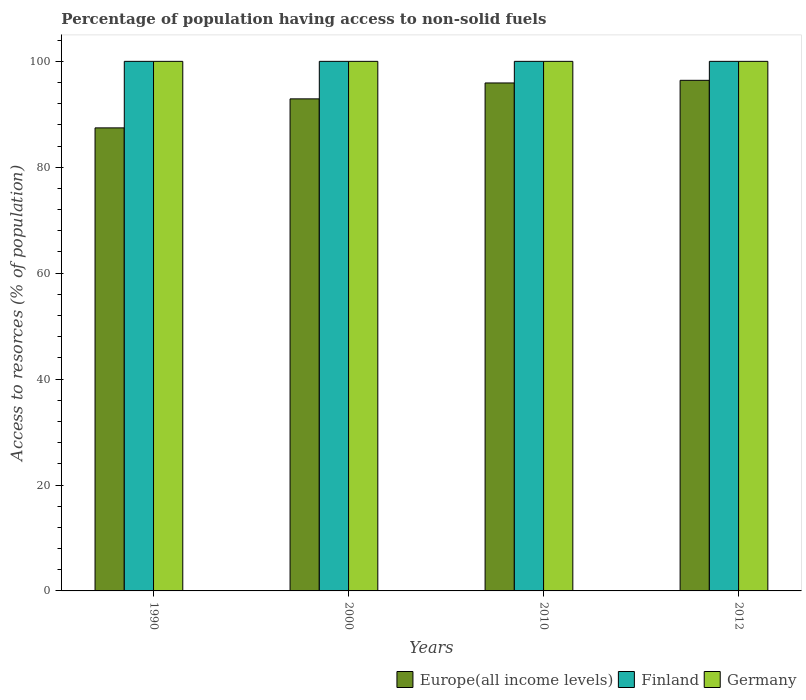How many groups of bars are there?
Provide a succinct answer. 4. Are the number of bars on each tick of the X-axis equal?
Offer a very short reply. Yes. How many bars are there on the 1st tick from the left?
Give a very brief answer. 3. How many bars are there on the 1st tick from the right?
Your answer should be very brief. 3. What is the label of the 1st group of bars from the left?
Ensure brevity in your answer.  1990. In how many cases, is the number of bars for a given year not equal to the number of legend labels?
Provide a short and direct response. 0. What is the percentage of population having access to non-solid fuels in Germany in 2012?
Give a very brief answer. 100. Across all years, what is the maximum percentage of population having access to non-solid fuels in Germany?
Provide a succinct answer. 100. Across all years, what is the minimum percentage of population having access to non-solid fuels in Europe(all income levels)?
Provide a succinct answer. 87.44. What is the total percentage of population having access to non-solid fuels in Finland in the graph?
Your response must be concise. 400. What is the difference between the percentage of population having access to non-solid fuels in Europe(all income levels) in 1990 and that in 2010?
Provide a short and direct response. -8.49. What is the difference between the percentage of population having access to non-solid fuels in Finland in 2012 and the percentage of population having access to non-solid fuels in Germany in 1990?
Give a very brief answer. 0. What is the average percentage of population having access to non-solid fuels in Germany per year?
Your response must be concise. 100. In the year 2010, what is the difference between the percentage of population having access to non-solid fuels in Europe(all income levels) and percentage of population having access to non-solid fuels in Germany?
Your answer should be very brief. -4.08. What is the ratio of the percentage of population having access to non-solid fuels in Germany in 2010 to that in 2012?
Ensure brevity in your answer.  1. Is the difference between the percentage of population having access to non-solid fuels in Europe(all income levels) in 1990 and 2010 greater than the difference between the percentage of population having access to non-solid fuels in Germany in 1990 and 2010?
Offer a terse response. No. What is the difference between the highest and the second highest percentage of population having access to non-solid fuels in Finland?
Provide a succinct answer. 0. Is the sum of the percentage of population having access to non-solid fuels in Germany in 2000 and 2010 greater than the maximum percentage of population having access to non-solid fuels in Finland across all years?
Your response must be concise. Yes. What does the 1st bar from the left in 2012 represents?
Ensure brevity in your answer.  Europe(all income levels). Are all the bars in the graph horizontal?
Give a very brief answer. No. Does the graph contain any zero values?
Make the answer very short. No. How many legend labels are there?
Ensure brevity in your answer.  3. What is the title of the graph?
Your answer should be very brief. Percentage of population having access to non-solid fuels. What is the label or title of the Y-axis?
Provide a short and direct response. Access to resorces (% of population). What is the Access to resorces (% of population) in Europe(all income levels) in 1990?
Provide a short and direct response. 87.44. What is the Access to resorces (% of population) of Germany in 1990?
Offer a terse response. 100. What is the Access to resorces (% of population) of Europe(all income levels) in 2000?
Make the answer very short. 92.92. What is the Access to resorces (% of population) in Europe(all income levels) in 2010?
Your answer should be very brief. 95.92. What is the Access to resorces (% of population) in Europe(all income levels) in 2012?
Your response must be concise. 96.42. What is the Access to resorces (% of population) in Germany in 2012?
Offer a terse response. 100. Across all years, what is the maximum Access to resorces (% of population) of Europe(all income levels)?
Ensure brevity in your answer.  96.42. Across all years, what is the minimum Access to resorces (% of population) of Europe(all income levels)?
Your answer should be very brief. 87.44. Across all years, what is the minimum Access to resorces (% of population) in Finland?
Make the answer very short. 100. What is the total Access to resorces (% of population) in Europe(all income levels) in the graph?
Offer a terse response. 372.69. What is the total Access to resorces (% of population) in Finland in the graph?
Offer a terse response. 400. What is the total Access to resorces (% of population) in Germany in the graph?
Keep it short and to the point. 400. What is the difference between the Access to resorces (% of population) in Europe(all income levels) in 1990 and that in 2000?
Your answer should be compact. -5.48. What is the difference between the Access to resorces (% of population) of Europe(all income levels) in 1990 and that in 2010?
Ensure brevity in your answer.  -8.49. What is the difference between the Access to resorces (% of population) of Germany in 1990 and that in 2010?
Make the answer very short. 0. What is the difference between the Access to resorces (% of population) of Europe(all income levels) in 1990 and that in 2012?
Your answer should be very brief. -8.98. What is the difference between the Access to resorces (% of population) of Finland in 1990 and that in 2012?
Offer a terse response. 0. What is the difference between the Access to resorces (% of population) in Europe(all income levels) in 2000 and that in 2010?
Your answer should be very brief. -3.01. What is the difference between the Access to resorces (% of population) of Finland in 2000 and that in 2010?
Ensure brevity in your answer.  0. What is the difference between the Access to resorces (% of population) of Germany in 2000 and that in 2010?
Provide a succinct answer. 0. What is the difference between the Access to resorces (% of population) in Europe(all income levels) in 2000 and that in 2012?
Make the answer very short. -3.5. What is the difference between the Access to resorces (% of population) of Finland in 2000 and that in 2012?
Provide a succinct answer. 0. What is the difference between the Access to resorces (% of population) of Germany in 2000 and that in 2012?
Give a very brief answer. 0. What is the difference between the Access to resorces (% of population) in Europe(all income levels) in 2010 and that in 2012?
Your answer should be compact. -0.5. What is the difference between the Access to resorces (% of population) of Europe(all income levels) in 1990 and the Access to resorces (% of population) of Finland in 2000?
Ensure brevity in your answer.  -12.56. What is the difference between the Access to resorces (% of population) of Europe(all income levels) in 1990 and the Access to resorces (% of population) of Germany in 2000?
Ensure brevity in your answer.  -12.56. What is the difference between the Access to resorces (% of population) in Finland in 1990 and the Access to resorces (% of population) in Germany in 2000?
Your answer should be very brief. 0. What is the difference between the Access to resorces (% of population) of Europe(all income levels) in 1990 and the Access to resorces (% of population) of Finland in 2010?
Make the answer very short. -12.56. What is the difference between the Access to resorces (% of population) of Europe(all income levels) in 1990 and the Access to resorces (% of population) of Germany in 2010?
Provide a short and direct response. -12.56. What is the difference between the Access to resorces (% of population) of Finland in 1990 and the Access to resorces (% of population) of Germany in 2010?
Provide a short and direct response. 0. What is the difference between the Access to resorces (% of population) in Europe(all income levels) in 1990 and the Access to resorces (% of population) in Finland in 2012?
Provide a short and direct response. -12.56. What is the difference between the Access to resorces (% of population) in Europe(all income levels) in 1990 and the Access to resorces (% of population) in Germany in 2012?
Make the answer very short. -12.56. What is the difference between the Access to resorces (% of population) of Finland in 1990 and the Access to resorces (% of population) of Germany in 2012?
Provide a short and direct response. 0. What is the difference between the Access to resorces (% of population) of Europe(all income levels) in 2000 and the Access to resorces (% of population) of Finland in 2010?
Ensure brevity in your answer.  -7.08. What is the difference between the Access to resorces (% of population) in Europe(all income levels) in 2000 and the Access to resorces (% of population) in Germany in 2010?
Your answer should be compact. -7.08. What is the difference between the Access to resorces (% of population) in Finland in 2000 and the Access to resorces (% of population) in Germany in 2010?
Provide a short and direct response. 0. What is the difference between the Access to resorces (% of population) of Europe(all income levels) in 2000 and the Access to resorces (% of population) of Finland in 2012?
Your answer should be very brief. -7.08. What is the difference between the Access to resorces (% of population) of Europe(all income levels) in 2000 and the Access to resorces (% of population) of Germany in 2012?
Ensure brevity in your answer.  -7.08. What is the difference between the Access to resorces (% of population) in Finland in 2000 and the Access to resorces (% of population) in Germany in 2012?
Ensure brevity in your answer.  0. What is the difference between the Access to resorces (% of population) in Europe(all income levels) in 2010 and the Access to resorces (% of population) in Finland in 2012?
Give a very brief answer. -4.08. What is the difference between the Access to resorces (% of population) in Europe(all income levels) in 2010 and the Access to resorces (% of population) in Germany in 2012?
Your answer should be compact. -4.08. What is the average Access to resorces (% of population) in Europe(all income levels) per year?
Give a very brief answer. 93.17. What is the average Access to resorces (% of population) of Finland per year?
Make the answer very short. 100. What is the average Access to resorces (% of population) in Germany per year?
Your answer should be compact. 100. In the year 1990, what is the difference between the Access to resorces (% of population) in Europe(all income levels) and Access to resorces (% of population) in Finland?
Your answer should be very brief. -12.56. In the year 1990, what is the difference between the Access to resorces (% of population) in Europe(all income levels) and Access to resorces (% of population) in Germany?
Provide a short and direct response. -12.56. In the year 1990, what is the difference between the Access to resorces (% of population) in Finland and Access to resorces (% of population) in Germany?
Offer a very short reply. 0. In the year 2000, what is the difference between the Access to resorces (% of population) in Europe(all income levels) and Access to resorces (% of population) in Finland?
Your response must be concise. -7.08. In the year 2000, what is the difference between the Access to resorces (% of population) of Europe(all income levels) and Access to resorces (% of population) of Germany?
Offer a terse response. -7.08. In the year 2010, what is the difference between the Access to resorces (% of population) of Europe(all income levels) and Access to resorces (% of population) of Finland?
Provide a succinct answer. -4.08. In the year 2010, what is the difference between the Access to resorces (% of population) of Europe(all income levels) and Access to resorces (% of population) of Germany?
Provide a succinct answer. -4.08. In the year 2010, what is the difference between the Access to resorces (% of population) of Finland and Access to resorces (% of population) of Germany?
Your response must be concise. 0. In the year 2012, what is the difference between the Access to resorces (% of population) in Europe(all income levels) and Access to resorces (% of population) in Finland?
Ensure brevity in your answer.  -3.58. In the year 2012, what is the difference between the Access to resorces (% of population) of Europe(all income levels) and Access to resorces (% of population) of Germany?
Keep it short and to the point. -3.58. What is the ratio of the Access to resorces (% of population) in Europe(all income levels) in 1990 to that in 2000?
Give a very brief answer. 0.94. What is the ratio of the Access to resorces (% of population) of Finland in 1990 to that in 2000?
Give a very brief answer. 1. What is the ratio of the Access to resorces (% of population) in Europe(all income levels) in 1990 to that in 2010?
Give a very brief answer. 0.91. What is the ratio of the Access to resorces (% of population) in Finland in 1990 to that in 2010?
Provide a short and direct response. 1. What is the ratio of the Access to resorces (% of population) in Germany in 1990 to that in 2010?
Your answer should be very brief. 1. What is the ratio of the Access to resorces (% of population) in Europe(all income levels) in 1990 to that in 2012?
Give a very brief answer. 0.91. What is the ratio of the Access to resorces (% of population) of Finland in 1990 to that in 2012?
Your answer should be compact. 1. What is the ratio of the Access to resorces (% of population) of Germany in 1990 to that in 2012?
Your answer should be very brief. 1. What is the ratio of the Access to resorces (% of population) in Europe(all income levels) in 2000 to that in 2010?
Your response must be concise. 0.97. What is the ratio of the Access to resorces (% of population) of Germany in 2000 to that in 2010?
Make the answer very short. 1. What is the ratio of the Access to resorces (% of population) of Europe(all income levels) in 2000 to that in 2012?
Your answer should be compact. 0.96. What is the ratio of the Access to resorces (% of population) in Germany in 2000 to that in 2012?
Offer a very short reply. 1. What is the ratio of the Access to resorces (% of population) in Germany in 2010 to that in 2012?
Your answer should be compact. 1. What is the difference between the highest and the second highest Access to resorces (% of population) of Europe(all income levels)?
Provide a succinct answer. 0.5. What is the difference between the highest and the second highest Access to resorces (% of population) of Finland?
Your answer should be compact. 0. What is the difference between the highest and the lowest Access to resorces (% of population) of Europe(all income levels)?
Your response must be concise. 8.98. What is the difference between the highest and the lowest Access to resorces (% of population) in Finland?
Your answer should be very brief. 0. What is the difference between the highest and the lowest Access to resorces (% of population) in Germany?
Provide a succinct answer. 0. 